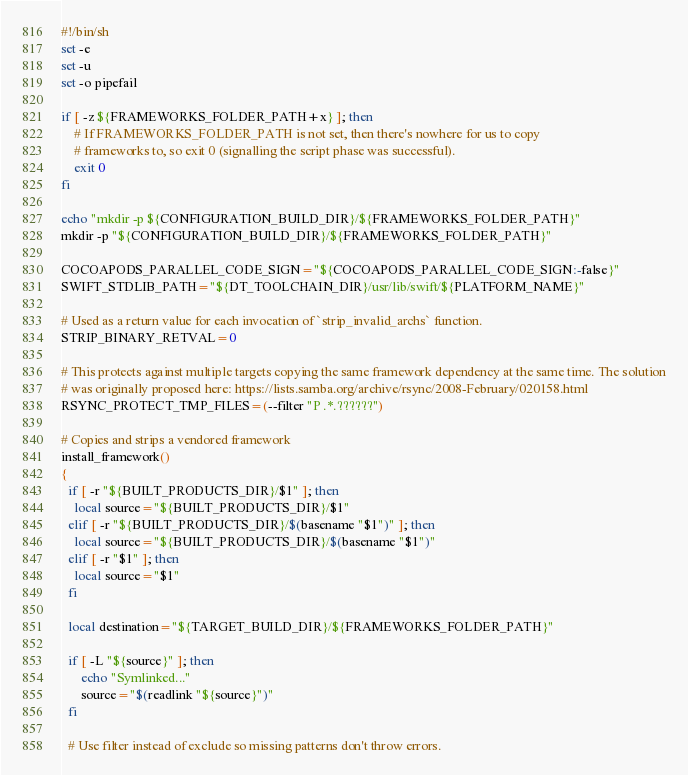<code> <loc_0><loc_0><loc_500><loc_500><_Bash_>#!/bin/sh
set -e
set -u
set -o pipefail

if [ -z ${FRAMEWORKS_FOLDER_PATH+x} ]; then
    # If FRAMEWORKS_FOLDER_PATH is not set, then there's nowhere for us to copy
    # frameworks to, so exit 0 (signalling the script phase was successful).
    exit 0
fi

echo "mkdir -p ${CONFIGURATION_BUILD_DIR}/${FRAMEWORKS_FOLDER_PATH}"
mkdir -p "${CONFIGURATION_BUILD_DIR}/${FRAMEWORKS_FOLDER_PATH}"

COCOAPODS_PARALLEL_CODE_SIGN="${COCOAPODS_PARALLEL_CODE_SIGN:-false}"
SWIFT_STDLIB_PATH="${DT_TOOLCHAIN_DIR}/usr/lib/swift/${PLATFORM_NAME}"

# Used as a return value for each invocation of `strip_invalid_archs` function.
STRIP_BINARY_RETVAL=0

# This protects against multiple targets copying the same framework dependency at the same time. The solution
# was originally proposed here: https://lists.samba.org/archive/rsync/2008-February/020158.html
RSYNC_PROTECT_TMP_FILES=(--filter "P .*.??????")

# Copies and strips a vendored framework
install_framework()
{
  if [ -r "${BUILT_PRODUCTS_DIR}/$1" ]; then
    local source="${BUILT_PRODUCTS_DIR}/$1"
  elif [ -r "${BUILT_PRODUCTS_DIR}/$(basename "$1")" ]; then
    local source="${BUILT_PRODUCTS_DIR}/$(basename "$1")"
  elif [ -r "$1" ]; then
    local source="$1"
  fi

  local destination="${TARGET_BUILD_DIR}/${FRAMEWORKS_FOLDER_PATH}"

  if [ -L "${source}" ]; then
      echo "Symlinked..."
      source="$(readlink "${source}")"
  fi

  # Use filter instead of exclude so missing patterns don't throw errors.</code> 